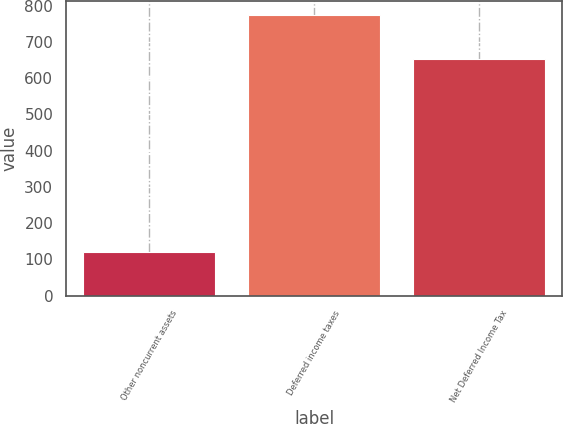<chart> <loc_0><loc_0><loc_500><loc_500><bar_chart><fcel>Other noncurrent assets<fcel>Deferred income taxes<fcel>Net Deferred Income Tax<nl><fcel>121.4<fcel>775.1<fcel>653.7<nl></chart> 